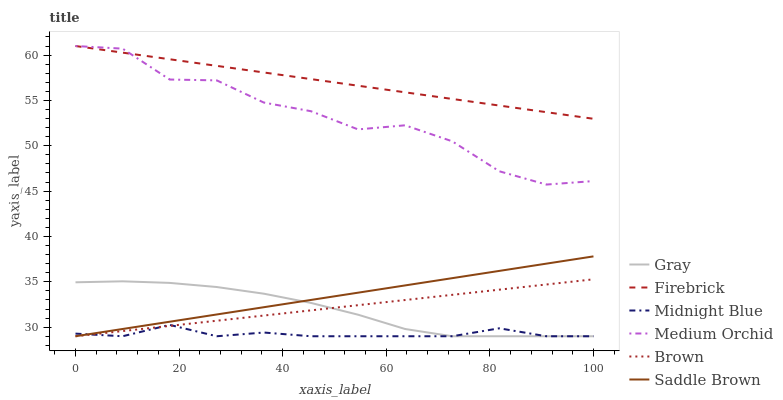Does Midnight Blue have the minimum area under the curve?
Answer yes or no. Yes. Does Firebrick have the maximum area under the curve?
Answer yes or no. Yes. Does Brown have the minimum area under the curve?
Answer yes or no. No. Does Brown have the maximum area under the curve?
Answer yes or no. No. Is Saddle Brown the smoothest?
Answer yes or no. Yes. Is Medium Orchid the roughest?
Answer yes or no. Yes. Is Midnight Blue the smoothest?
Answer yes or no. No. Is Midnight Blue the roughest?
Answer yes or no. No. Does Gray have the lowest value?
Answer yes or no. Yes. Does Firebrick have the lowest value?
Answer yes or no. No. Does Medium Orchid have the highest value?
Answer yes or no. Yes. Does Brown have the highest value?
Answer yes or no. No. Is Gray less than Medium Orchid?
Answer yes or no. Yes. Is Firebrick greater than Saddle Brown?
Answer yes or no. Yes. Does Midnight Blue intersect Saddle Brown?
Answer yes or no. Yes. Is Midnight Blue less than Saddle Brown?
Answer yes or no. No. Is Midnight Blue greater than Saddle Brown?
Answer yes or no. No. Does Gray intersect Medium Orchid?
Answer yes or no. No. 